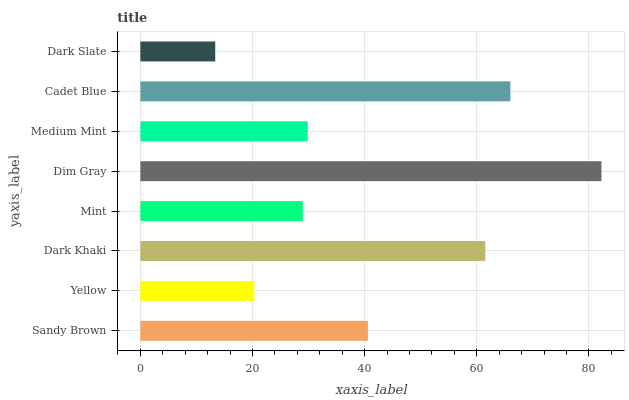Is Dark Slate the minimum?
Answer yes or no. Yes. Is Dim Gray the maximum?
Answer yes or no. Yes. Is Yellow the minimum?
Answer yes or no. No. Is Yellow the maximum?
Answer yes or no. No. Is Sandy Brown greater than Yellow?
Answer yes or no. Yes. Is Yellow less than Sandy Brown?
Answer yes or no. Yes. Is Yellow greater than Sandy Brown?
Answer yes or no. No. Is Sandy Brown less than Yellow?
Answer yes or no. No. Is Sandy Brown the high median?
Answer yes or no. Yes. Is Medium Mint the low median?
Answer yes or no. Yes. Is Cadet Blue the high median?
Answer yes or no. No. Is Yellow the low median?
Answer yes or no. No. 